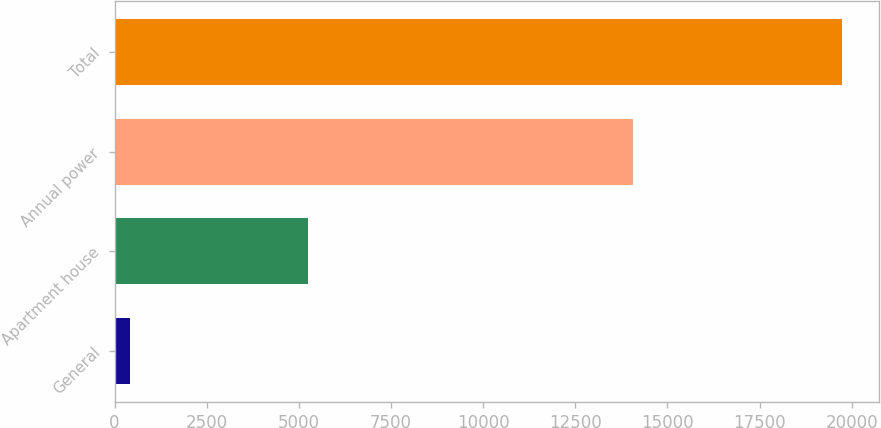Convert chart. <chart><loc_0><loc_0><loc_500><loc_500><bar_chart><fcel>General<fcel>Apartment house<fcel>Annual power<fcel>Total<nl><fcel>425<fcel>5240<fcel>14076<fcel>19741<nl></chart> 